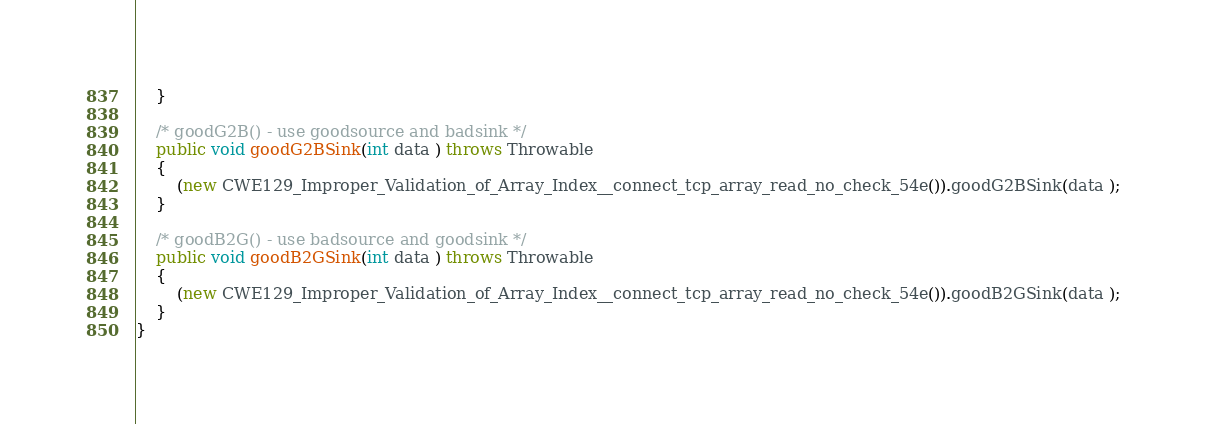<code> <loc_0><loc_0><loc_500><loc_500><_Java_>    }

    /* goodG2B() - use goodsource and badsink */
    public void goodG2BSink(int data ) throws Throwable
    {
        (new CWE129_Improper_Validation_of_Array_Index__connect_tcp_array_read_no_check_54e()).goodG2BSink(data );
    }

    /* goodB2G() - use badsource and goodsink */
    public void goodB2GSink(int data ) throws Throwable
    {
        (new CWE129_Improper_Validation_of_Array_Index__connect_tcp_array_read_no_check_54e()).goodB2GSink(data );
    }
}
</code> 